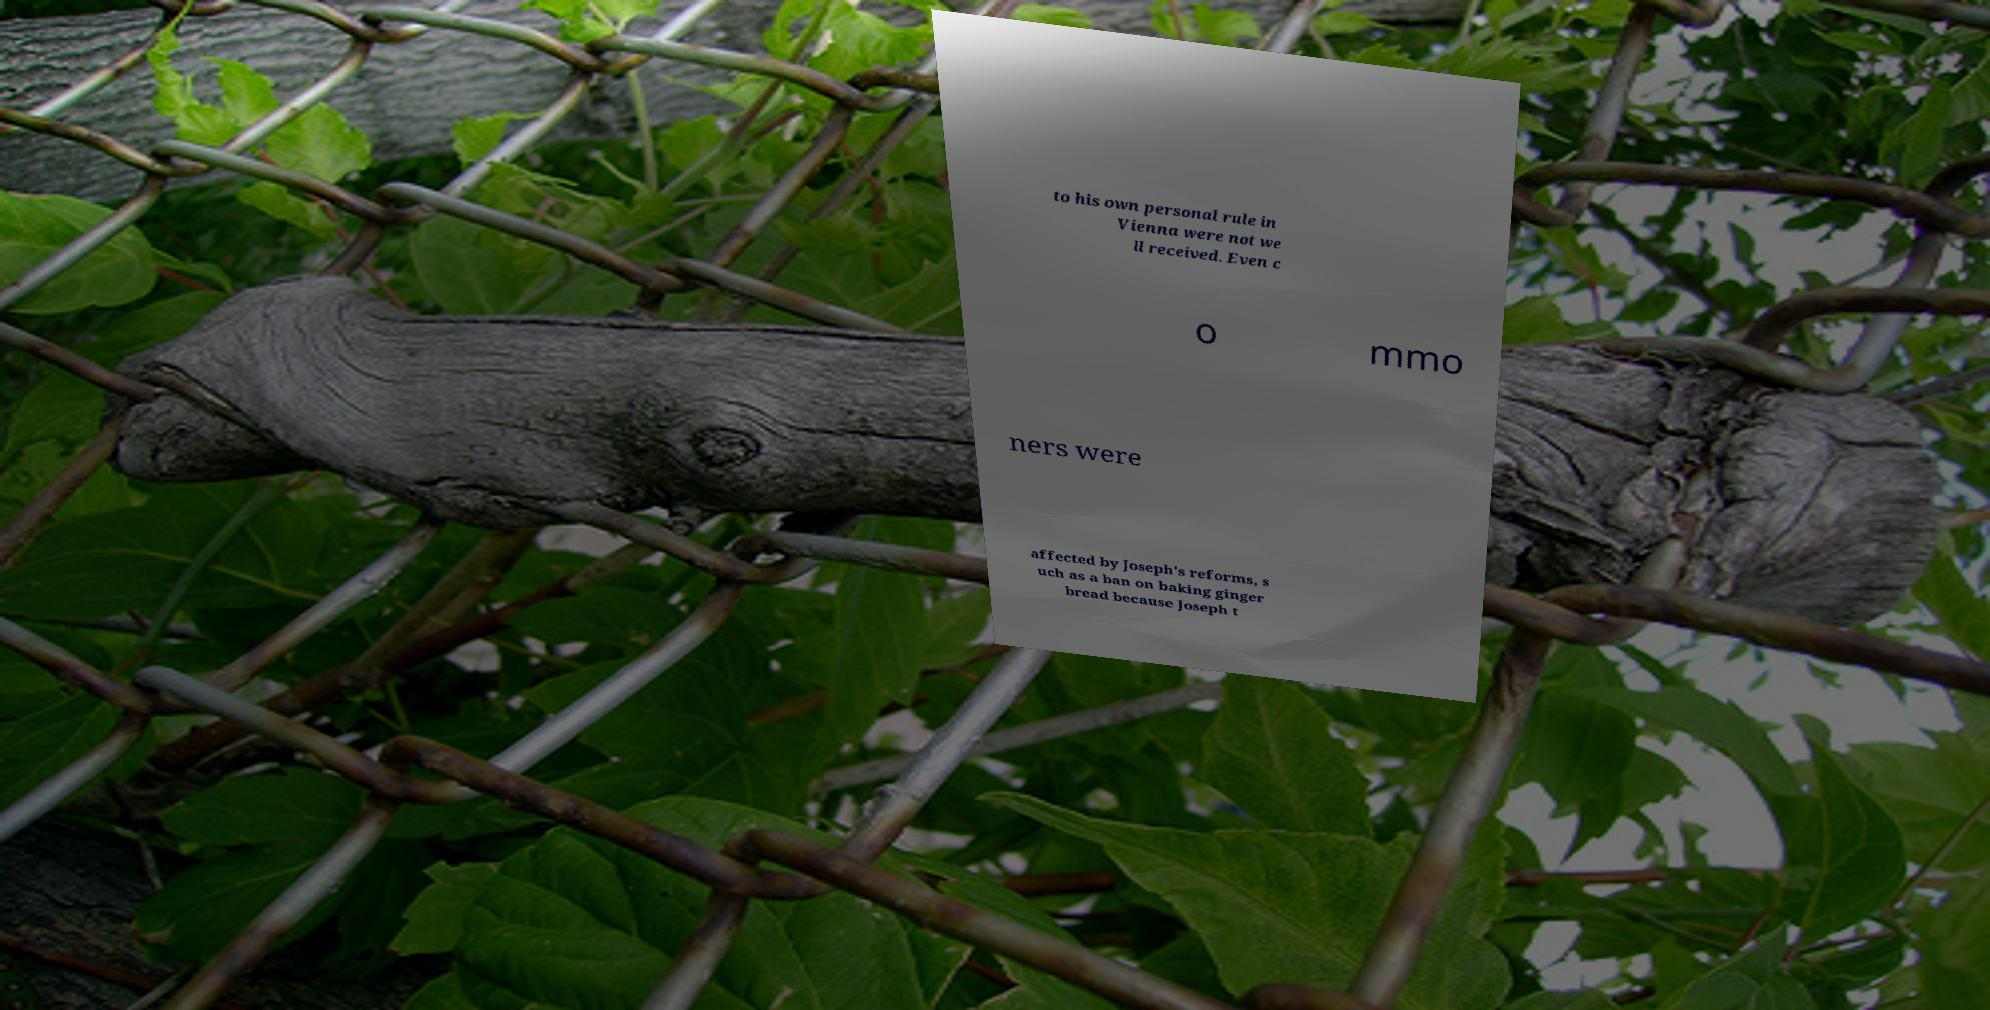For documentation purposes, I need the text within this image transcribed. Could you provide that? to his own personal rule in Vienna were not we ll received. Even c o mmo ners were affected by Joseph's reforms, s uch as a ban on baking ginger bread because Joseph t 